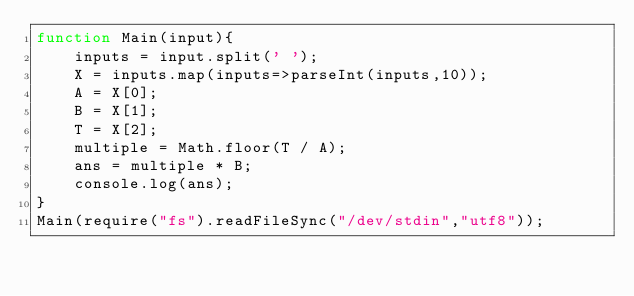<code> <loc_0><loc_0><loc_500><loc_500><_JavaScript_>function Main(input){
	inputs = input.split(' ');
    X = inputs.map(inputs=>parseInt(inputs,10));
    A = X[0];
    B = X[1];
    T = X[2];
    multiple = Math.floor(T / A);
    ans = multiple * B;
    console.log(ans);
}
Main(require("fs").readFileSync("/dev/stdin","utf8"));</code> 